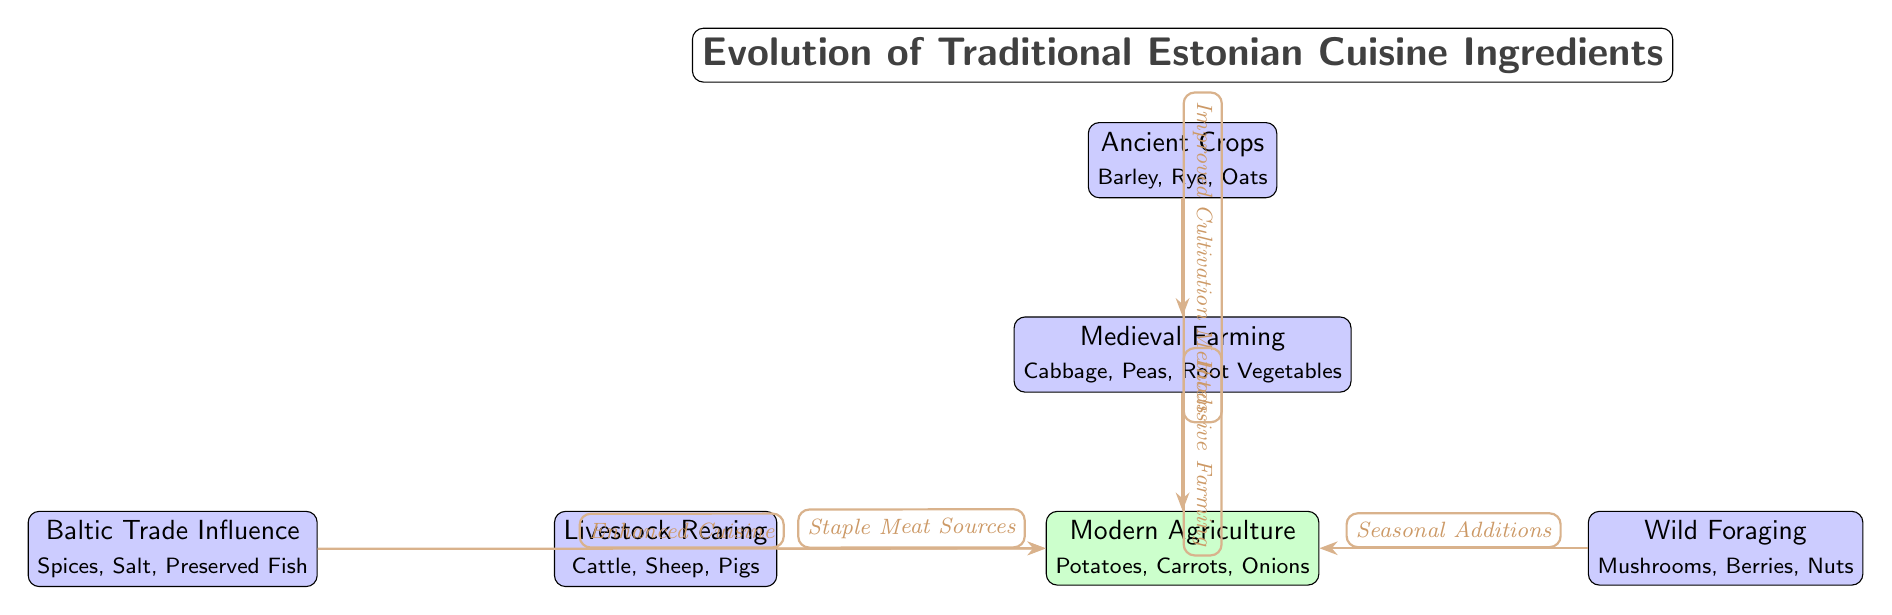What are the ancient crops mentioned in the diagram? The diagram lists ancient crops as barley, rye, and oats, which are directly stated in the "Ancient Crops" node.
Answer: Barley, Rye, Oats How many source nodes are in the diagram? The diagram contains five source nodes, which include the Ancient Crops, Medieval Farming, Livestock Rearing, Wild Foraging, and Baltic Trade Influence nodes.
Answer: 5 What farming practice led to the development of modern agriculture? The "Medieval Farming" node connects to the "Modern Agriculture" node through "Intensive Farming," indicating this practice contributes to modern agriculture.
Answer: Intensive Farming Which ingredient category is associated with "Staple Meat Sources"? The "Staple Meat Sources" is connected to the "Livestock Rearing" node, identifying it as the ingredient category related to it.
Answer: Livestock Rearing What ingredient is a product of the Baltic Trade Influence? The "Baltic Trade Influence" node lists spices, salt, and preserved fish, showing these ingredients are direct products of this influence.
Answer: Spices, Salt, Preserved Fish Explain the relationship between wild foraging and modern agriculture. The "Wild Foraging" node is related to modern agriculture through "Seasonal Additions," suggesting that foraged foods are incorporated into contemporary dietary practices, thus linking them.
Answer: Seasonal Additions How many different types of ingredients are linked to modern agriculture? The diagram connects four types of ingredients to modern agriculture: potatoes, carrots, onions, and the three types from livestock rearing, wild foraging, and Baltic trade, totaling seven.
Answer: 7 What method improved cultivation from ancient crops to medieval farming? The diagram indicates that the transition from ancient crops to medieval farming was facilitated by "Improved Cultivation Methods." This phrase connects these two nodes, suggesting it is the specified method.
Answer: Improved Cultivation Methods 